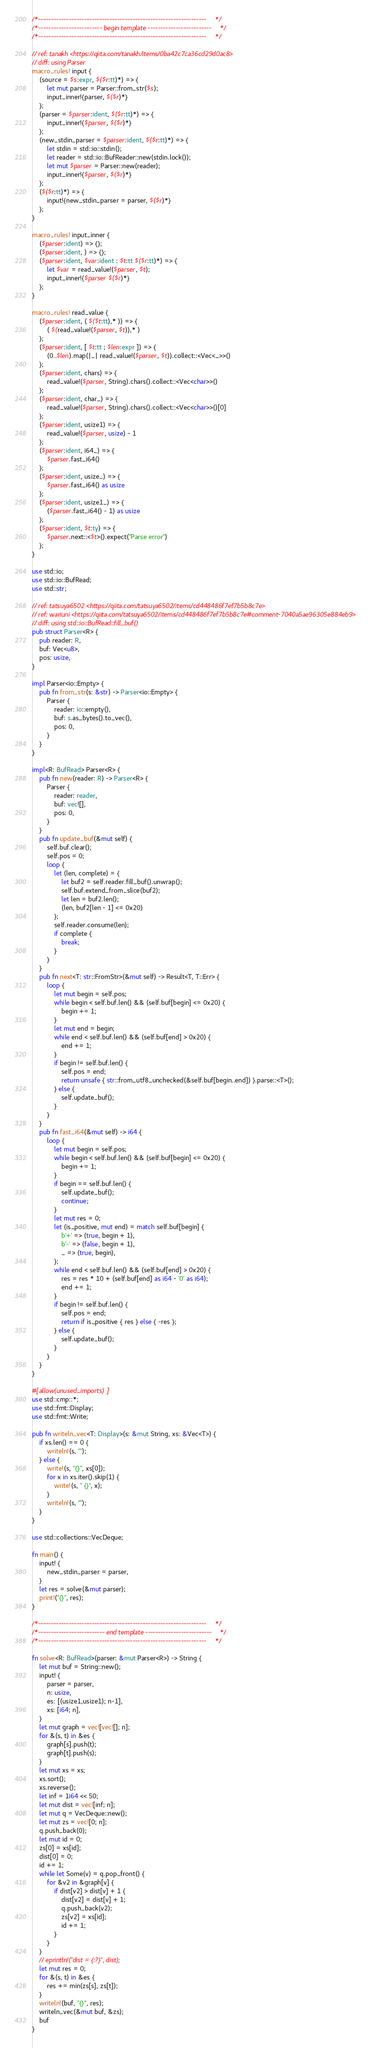<code> <loc_0><loc_0><loc_500><loc_500><_Rust_>/*------------------------------------------------------------------*/
/*------------------------- begin template -------------------------*/
/*------------------------------------------------------------------*/

// ref: tanakh <https://qiita.com/tanakh/items/0ba42c7ca36cd29d0ac8>
// diff: using Parser
macro_rules! input {
    (source = $s:expr, $($r:tt)*) => {
        let mut parser = Parser::from_str($s);
        input_inner!{parser, $($r)*}
    };
    (parser = $parser:ident, $($r:tt)*) => {
        input_inner!{$parser, $($r)*}
    };
    (new_stdin_parser = $parser:ident, $($r:tt)*) => {
        let stdin = std::io::stdin();
        let reader = std::io::BufReader::new(stdin.lock());
        let mut $parser = Parser::new(reader);
        input_inner!{$parser, $($r)*}
    };
    ($($r:tt)*) => {
        input!{new_stdin_parser = parser, $($r)*}
    };
}

macro_rules! input_inner {
    ($parser:ident) => {};
    ($parser:ident, ) => {};
    ($parser:ident, $var:ident : $t:tt $($r:tt)*) => {
        let $var = read_value!($parser, $t);
        input_inner!{$parser $($r)*}
    };
}

macro_rules! read_value {
    ($parser:ident, ( $($t:tt),* )) => {
        ( $(read_value!($parser, $t)),* )
    };
    ($parser:ident, [ $t:tt ; $len:expr ]) => {
        (0..$len).map(|_| read_value!($parser, $t)).collect::<Vec<_>>()
    };
    ($parser:ident, chars) => {
        read_value!($parser, String).chars().collect::<Vec<char>>()
    };
    ($parser:ident, char_) => {
        read_value!($parser, String).chars().collect::<Vec<char>>()[0]
    };
    ($parser:ident, usize1) => {
        read_value!($parser, usize) - 1
    };
    ($parser:ident, i64_) => {
        $parser.fast_i64()
    };
    ($parser:ident, usize_) => {
        $parser.fast_i64() as usize
    };
    ($parser:ident, usize1_) => {
        ($parser.fast_i64() - 1) as usize
    };
    ($parser:ident, $t:ty) => {
        $parser.next::<$t>().expect("Parse error")
    };
}

use std::io;
use std::io::BufRead;
use std::str;

// ref: tatsuya6502 <https://qiita.com/tatsuya6502/items/cd448486f7ef7b5b8c7e>
// ref: wariuni <https://qiita.com/tatsuya6502/items/cd448486f7ef7b5b8c7e#comment-7040a5ae96305e884eb9>
// diff: using std::io::BufRead::fill_buf()
pub struct Parser<R> {
    pub reader: R,
    buf: Vec<u8>,
    pos: usize,
}

impl Parser<io::Empty> {
    pub fn from_str(s: &str) -> Parser<io::Empty> {
        Parser {
            reader: io::empty(),
            buf: s.as_bytes().to_vec(),
            pos: 0,
        }
    }
}

impl<R: BufRead> Parser<R> {
    pub fn new(reader: R) -> Parser<R> {
        Parser {
            reader: reader,
            buf: vec![],
            pos: 0,
        }
    }
    pub fn update_buf(&mut self) {
        self.buf.clear();
        self.pos = 0;
        loop {
            let (len, complete) = {
                let buf2 = self.reader.fill_buf().unwrap();
                self.buf.extend_from_slice(buf2);
                let len = buf2.len();
                (len, buf2[len - 1] <= 0x20)
            };
            self.reader.consume(len);
            if complete {
                break;
            }
        }
    }
    pub fn next<T: str::FromStr>(&mut self) -> Result<T, T::Err> {
        loop {
            let mut begin = self.pos;
            while begin < self.buf.len() && (self.buf[begin] <= 0x20) {
                begin += 1;
            }
            let mut end = begin;
            while end < self.buf.len() && (self.buf[end] > 0x20) {
                end += 1;
            }
            if begin != self.buf.len() {
                self.pos = end;
                return unsafe { str::from_utf8_unchecked(&self.buf[begin..end]) }.parse::<T>();
            } else {
                self.update_buf();
            }
        }
    }
    pub fn fast_i64(&mut self) -> i64 {
        loop {
            let mut begin = self.pos;
            while begin < self.buf.len() && (self.buf[begin] <= 0x20) {
                begin += 1;
            }
            if begin == self.buf.len() {
                self.update_buf();
                continue;
            }
            let mut res = 0;
            let (is_positive, mut end) = match self.buf[begin] {
                b'+' => (true, begin + 1),
                b'-' => (false, begin + 1),
                _ => (true, begin),
            };
            while end < self.buf.len() && (self.buf[end] > 0x20) {
                res = res * 10 + (self.buf[end] as i64 - '0' as i64);
                end += 1;
            }
            if begin != self.buf.len() {
                self.pos = end;
                return if is_positive { res } else { -res };
            } else {
                self.update_buf();
            }
        }
    }
}

#[allow(unused_imports)]
use std::cmp::*;
use std::fmt::Display;
use std::fmt::Write;

pub fn writeln_vec<T: Display>(s: &mut String, xs: &Vec<T>) {
    if xs.len() == 0 {
        writeln!(s, "");
    } else {
        write!(s, "{}", xs[0]);
        for x in xs.iter().skip(1) {
            write!(s, " {}", x);
        }
        writeln!(s, "");
    }
}

use std::collections::VecDeque;

fn main() {
    input! {
        new_stdin_parser = parser,
    }
    let res = solve(&mut parser);
    print!("{}", res);
}

/*------------------------------------------------------------------*/
/*-------------------------- end template --------------------------*/
/*------------------------------------------------------------------*/

fn solve<R: BufRead>(parser: &mut Parser<R>) -> String {
    let mut buf = String::new();
    input! {
        parser = parser,
        n: usize,
        es: [(usize1,usize1); n-1],
        xs: [i64; n],
    }
    let mut graph = vec![vec![]; n];
    for &(s, t) in &es {
        graph[s].push(t);
        graph[t].push(s);
    }
    let mut xs = xs;
    xs.sort();
    xs.reverse();
    let inf = 1i64 << 50;
    let mut dist = vec![inf; n];
    let mut q = VecDeque::new();
    let mut zs = vec![0; n];
    q.push_back(0);
    let mut id = 0;
    zs[0] = xs[id];
    dist[0] = 0;
    id += 1;
    while let Some(v) = q.pop_front() {
        for &v2 in &graph[v] {
            if dist[v2] > dist[v] + 1 {
                dist[v2] = dist[v] + 1;
                q.push_back(v2);
                zs[v2] = xs[id];
                id += 1;
            }
        }
    }
    // eprintln!("dist = {:?}", dist);
    let mut res = 0;
    for &(s, t) in &es {
        res += min(zs[s], zs[t]);
    }
    writeln!(buf, "{}", res);
    writeln_vec(&mut buf, &zs);
    buf
}
</code> 